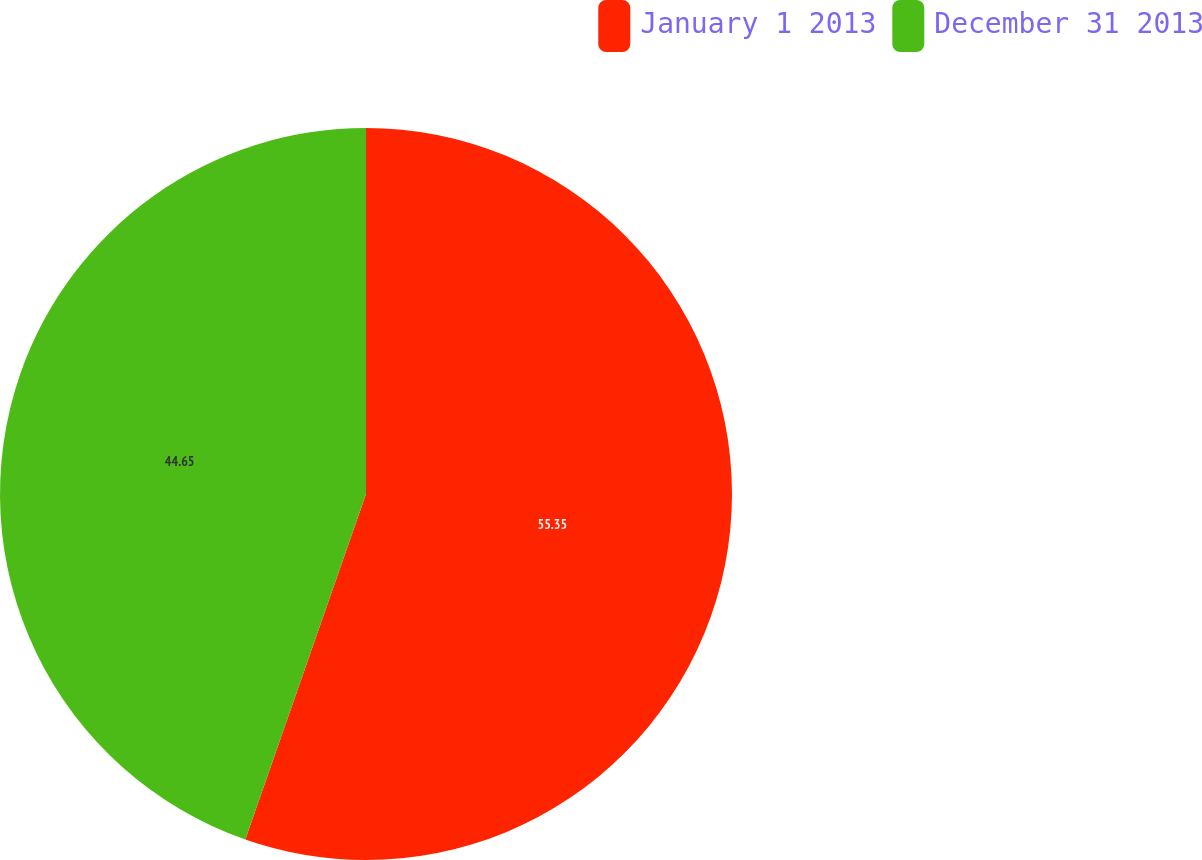<chart> <loc_0><loc_0><loc_500><loc_500><pie_chart><fcel>January 1 2013<fcel>December 31 2013<nl><fcel>55.35%<fcel>44.65%<nl></chart> 